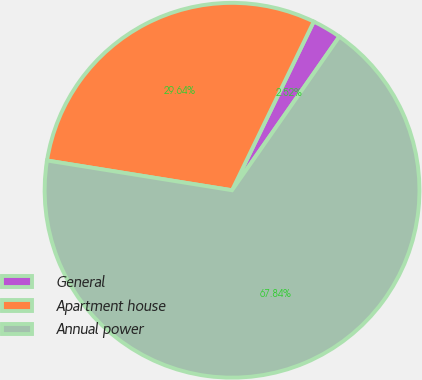Convert chart. <chart><loc_0><loc_0><loc_500><loc_500><pie_chart><fcel>General<fcel>Apartment house<fcel>Annual power<nl><fcel>2.52%<fcel>29.64%<fcel>67.83%<nl></chart> 